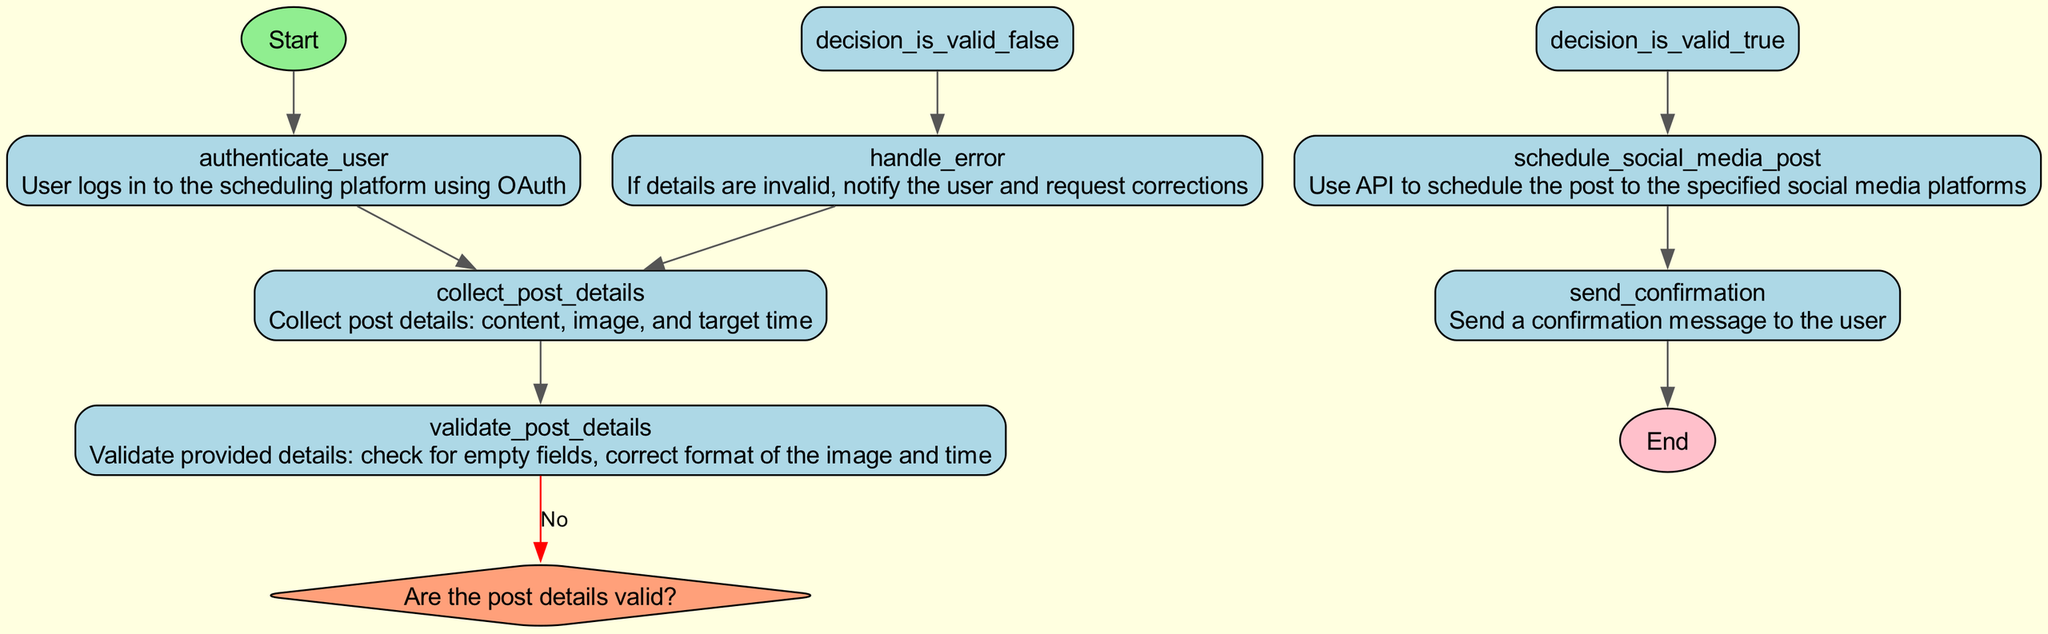What is the first node in the flowchart? The first node is labeled "Start the process of scheduling a social media post" and indicates the beginning of the flowchart's process.
Answer: Start What type of authentication is used? The flowchart specifies that user authentication occurs through OAuth, which indicates a secure connection for the scheduling platform.
Answer: OAuth How many processes are there in total? Counting the various processes in the diagram including validation, scheduling, error handling, there are four distinct process nodes listed in the flowchart.
Answer: Four What happens if the post details are valid? If the post details are valid, the flowchart indicates a green connection to the "schedule social media post" process, which means the post can be scheduled to the specified platforms.
Answer: Schedule the post What process occurs after sending a confirmation? After sending a confirmation, the next node in the flowchart is the "End of scheduling process," which indicates that the process has completed successfully.
Answer: End of scheduling process Which decision node leads to an error handling process? The decision node "is_valid" leads to the "handle_error" process when the post details are determined to be invalid (indicated by the 'No' pathway).
Answer: is_valid What does the output confirmation node signify? The output confirmation node indicates that a confirmation message is sent to the user once the social media post has been successfully scheduled.
Answer: Send a confirmation message What type of node is "input_scheduling_details"? The "input_scheduling_details" node is classified as an input node where the user collects necessary information for the post, such as content, image, and target time.
Answer: Input What is the final output of the scheduling process? The final output of the scheduling process is reached after sending a confirmation message to the user, marking the successful completion of the scheduling task.
Answer: Confirmation message 